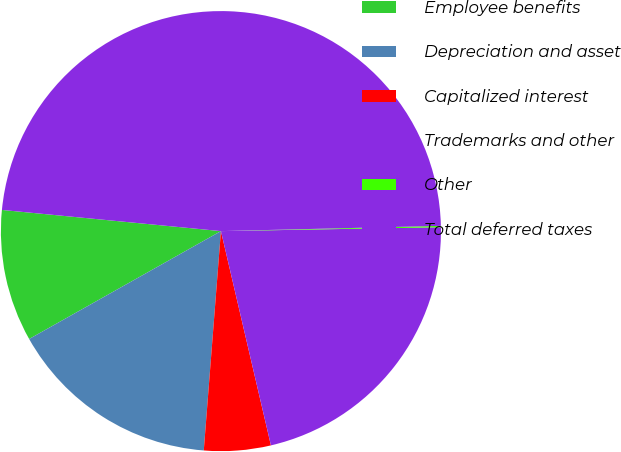Convert chart. <chart><loc_0><loc_0><loc_500><loc_500><pie_chart><fcel>Employee benefits<fcel>Depreciation and asset<fcel>Capitalized interest<fcel>Trademarks and other<fcel>Other<fcel>Total deferred taxes<nl><fcel>9.69%<fcel>15.6%<fcel>4.89%<fcel>21.63%<fcel>0.1%<fcel>48.08%<nl></chart> 